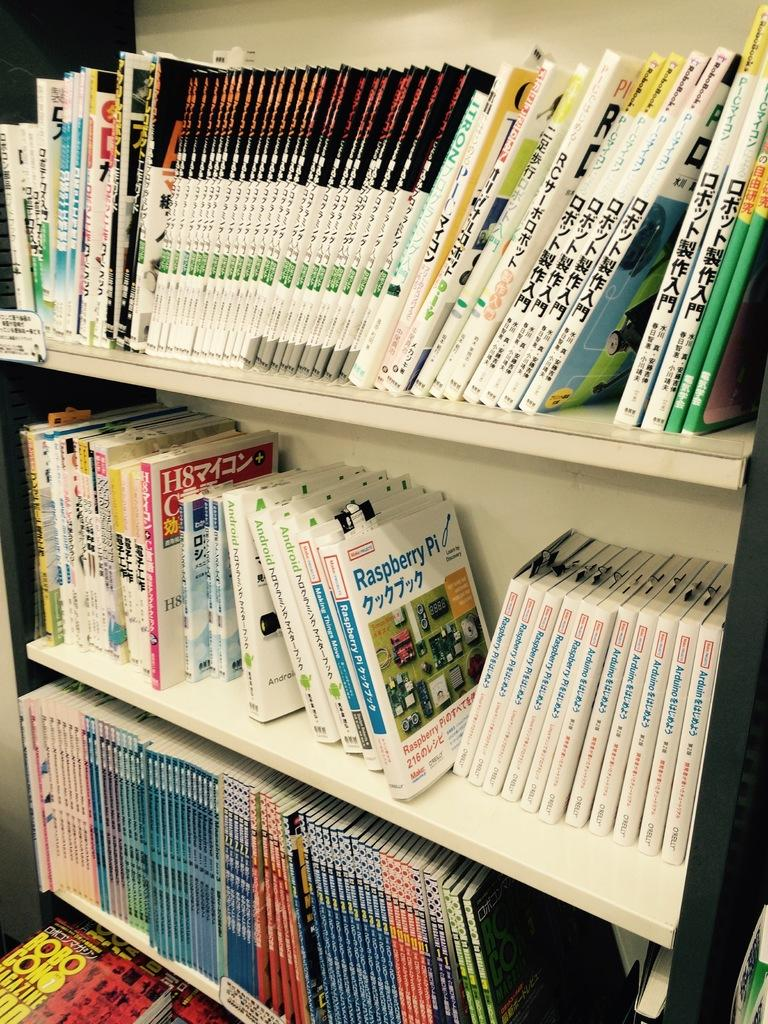<image>
Write a terse but informative summary of the picture. Books on technology like Android and Raspberry Pi fill shelves of a bookcase. 